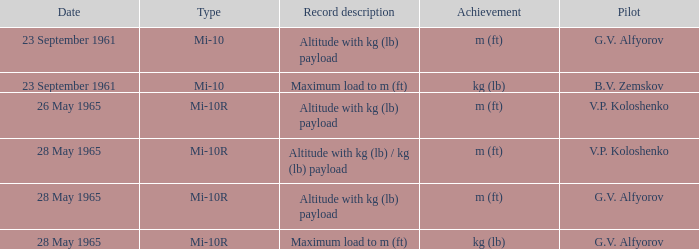Help me parse the entirety of this table. {'header': ['Date', 'Type', 'Record description', 'Achievement', 'Pilot'], 'rows': [['23 September 1961', 'Mi-10', 'Altitude with kg (lb) payload', 'm (ft)', 'G.V. Alfyorov'], ['23 September 1961', 'Mi-10', 'Maximum load to m (ft)', 'kg (lb)', 'B.V. Zemskov'], ['26 May 1965', 'Mi-10R', 'Altitude with kg (lb) payload', 'm (ft)', 'V.P. Koloshenko'], ['28 May 1965', 'Mi-10R', 'Altitude with kg (lb) / kg (lb) payload', 'm (ft)', 'V.P. Koloshenko'], ['28 May 1965', 'Mi-10R', 'Altitude with kg (lb) payload', 'm (ft)', 'G.V. Alfyorov'], ['28 May 1965', 'Mi-10R', 'Maximum load to m (ft)', 'kg (lb)', 'G.V. Alfyorov']]} Record description of maximum load to m (ft), and a Date of 23 september 1961 is what pilot? B.V. Zemskov. 